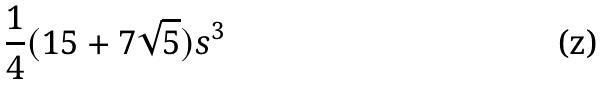Convert formula to latex. <formula><loc_0><loc_0><loc_500><loc_500>\frac { 1 } { 4 } ( 1 5 + 7 \sqrt { 5 } ) s ^ { 3 }</formula> 